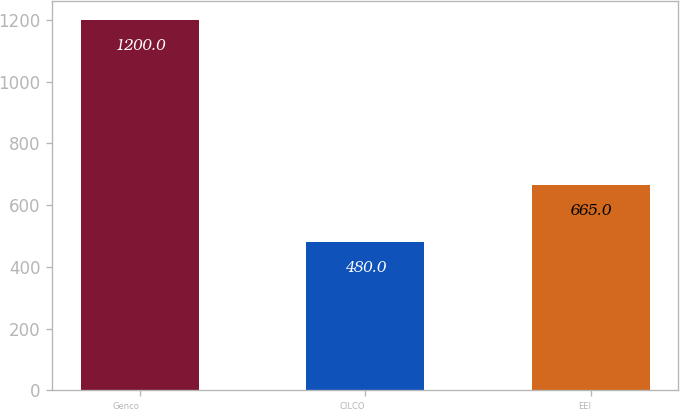<chart> <loc_0><loc_0><loc_500><loc_500><bar_chart><fcel>Genco<fcel>CILCO<fcel>EEI<nl><fcel>1200<fcel>480<fcel>665<nl></chart> 